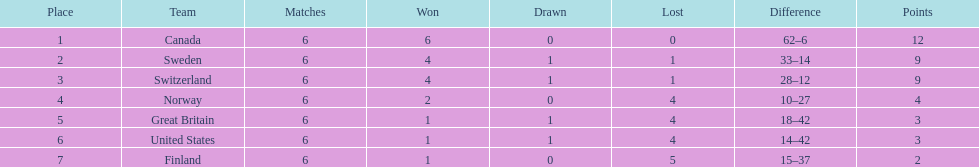Between finland and norway, which team has a higher number of match victories? Norway. 